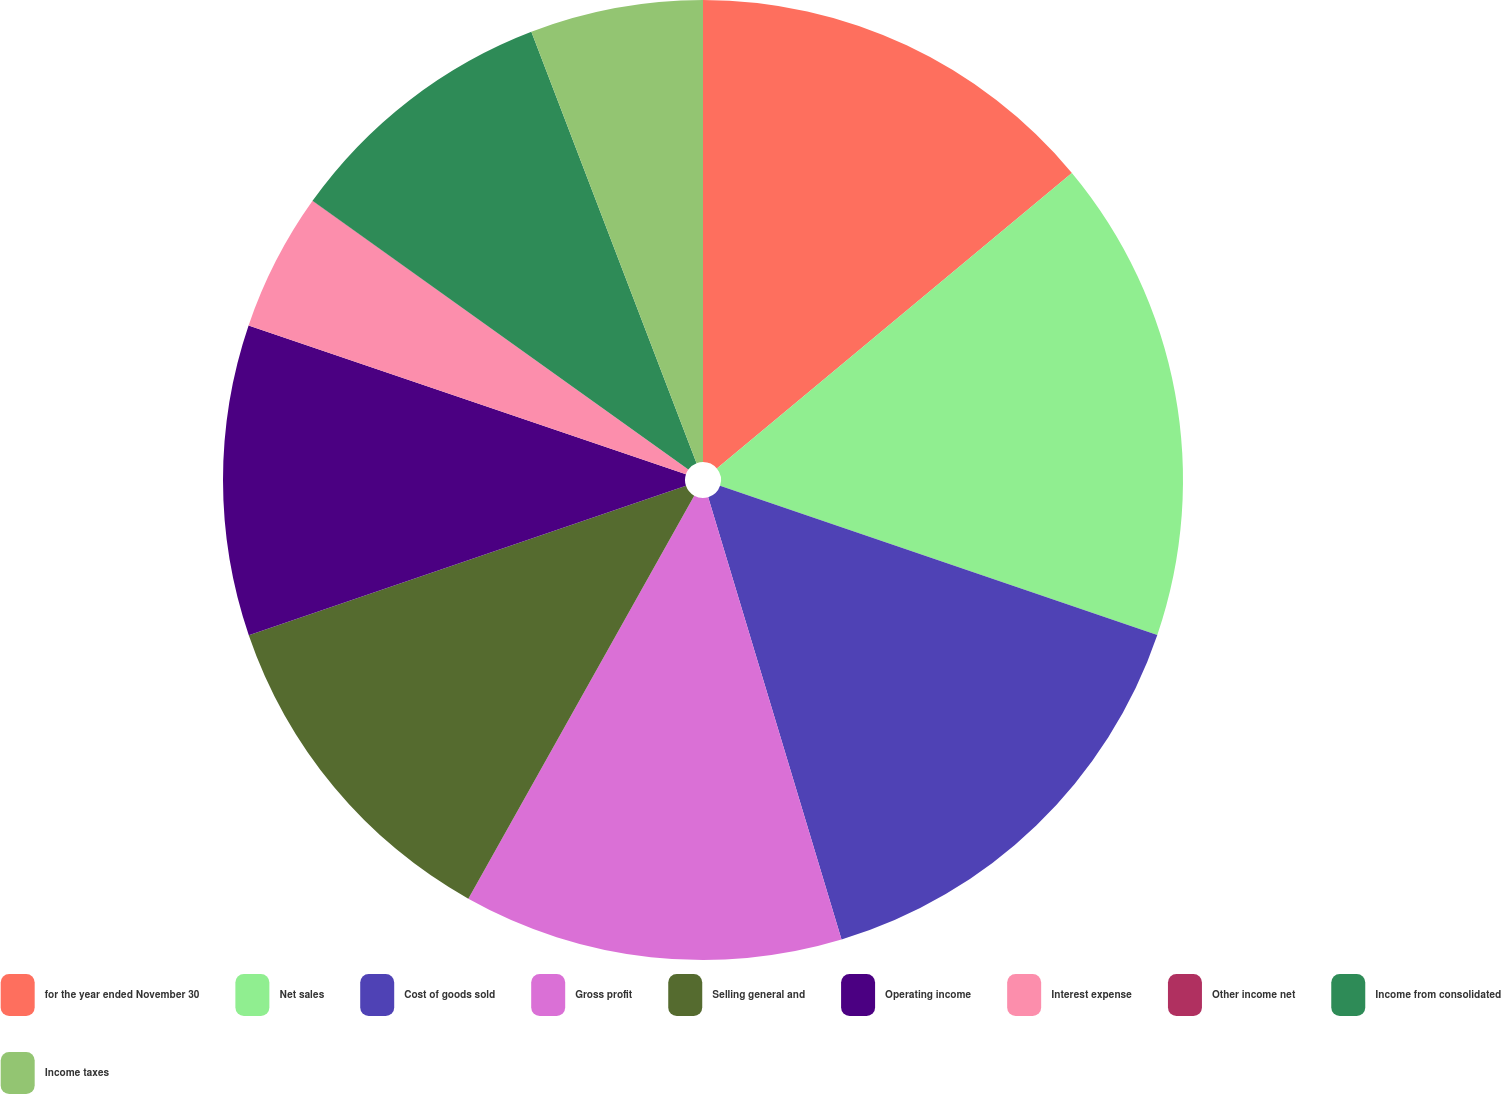<chart> <loc_0><loc_0><loc_500><loc_500><pie_chart><fcel>for the year ended November 30<fcel>Net sales<fcel>Cost of goods sold<fcel>Gross profit<fcel>Selling general and<fcel>Operating income<fcel>Interest expense<fcel>Other income net<fcel>Income from consolidated<fcel>Income taxes<nl><fcel>13.95%<fcel>16.28%<fcel>15.11%<fcel>12.79%<fcel>11.63%<fcel>10.46%<fcel>4.65%<fcel>0.01%<fcel>9.3%<fcel>5.82%<nl></chart> 